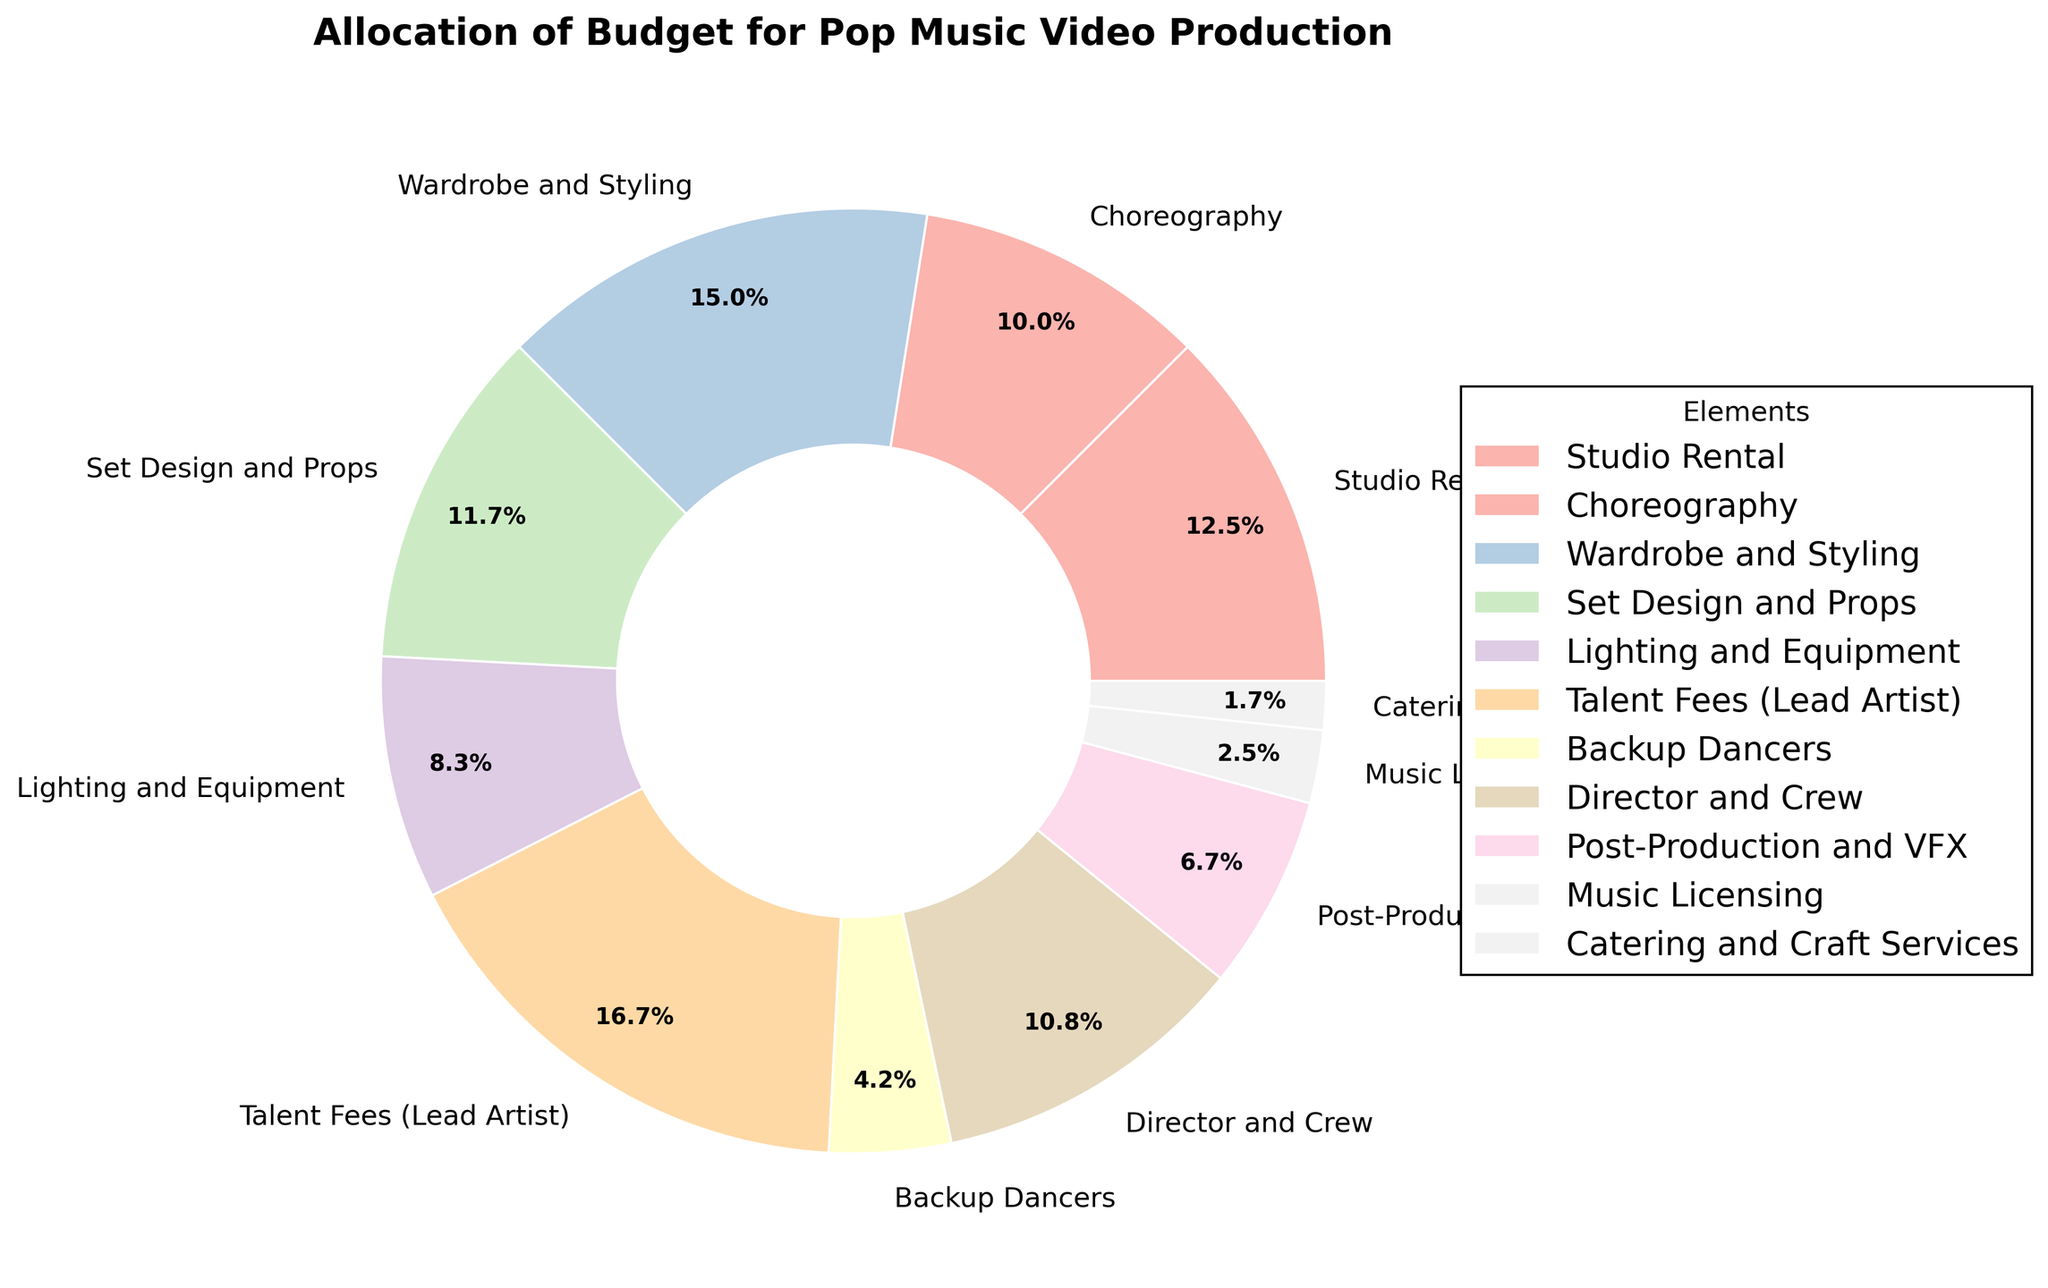Which element has the highest budget allocation? The pie chart shows percentages of budget allocations, and Talent Fees (Lead Artist) has the largest percentage.
Answer: Talent Fees (Lead Artist) Which element has the lowest budget allocation? The pie chart shows percentages of budget allocations, and Catering and Craft Services has the smallest percentage.
Answer: Catering and Craft Services How much more budget is allocated to Talent Fees (Lead Artist) than Backup Dancers? From the pie chart, Talent Fees (Lead Artist) are allocated 20%, and Backup Dancers are allocated 5%. The difference is 20% - 5% = 15%.
Answer: 15% What is the combined budget allocation for Wardrobe and Styling, and Set Design and Props? From the pie chart, Wardrobe and Styling is allocated 18%, and Set Design and Props is allocated 14%. The combined budget is 18% + 14% = 32%.
Answer: 32% How does the budget allocation for Lighting and Equipment compare to Post-Production and VFX? From the pie chart, Lighting and Equipment has a budget allocation of 10%, while Post-Production and VFX has 8%. Therefore, Lighting and Equipment has a larger allocation.
Answer: Lighting and Equipment What is the average budget allocation for Studio Rental, Choreography, and Director and Crew? Studio Rental is 15%, Choreography is 12%, and Director and Crew is 13%. The sum is 15% + 12% + 13% = 40%. The average is 40% / 3 = 13.33%.
Answer: 13.33% How much more budget is allocated to Wardrobe and Styling compared to Lighting and Equipment? Wardrobe and Styling is allocated 18%, and Lighting and Equipment is allocated 10%. The difference is 18% - 10% = 8%.
Answer: 8% Which has a higher allocation: Set Design and Props or Choreography? From the pie chart, Set Design and Props is allocated 14%, and Choreography is allocated 12%. Therefore, Set Design and Props has a higher allocation.
Answer: Set Design and Props 